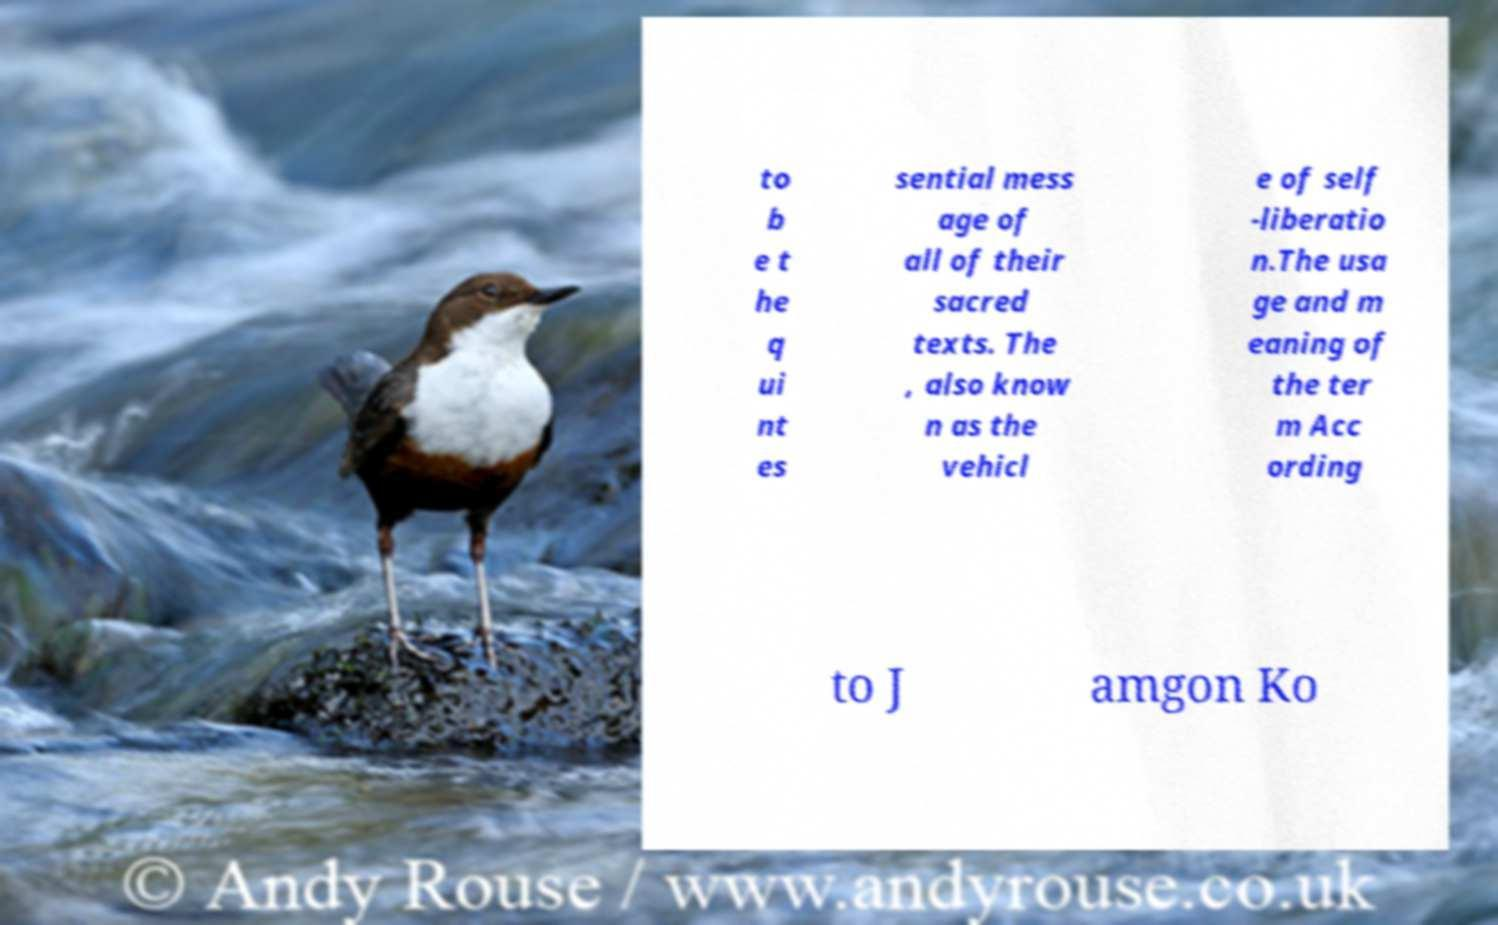Can you accurately transcribe the text from the provided image for me? to b e t he q ui nt es sential mess age of all of their sacred texts. The , also know n as the vehicl e of self -liberatio n.The usa ge and m eaning of the ter m Acc ording to J amgon Ko 